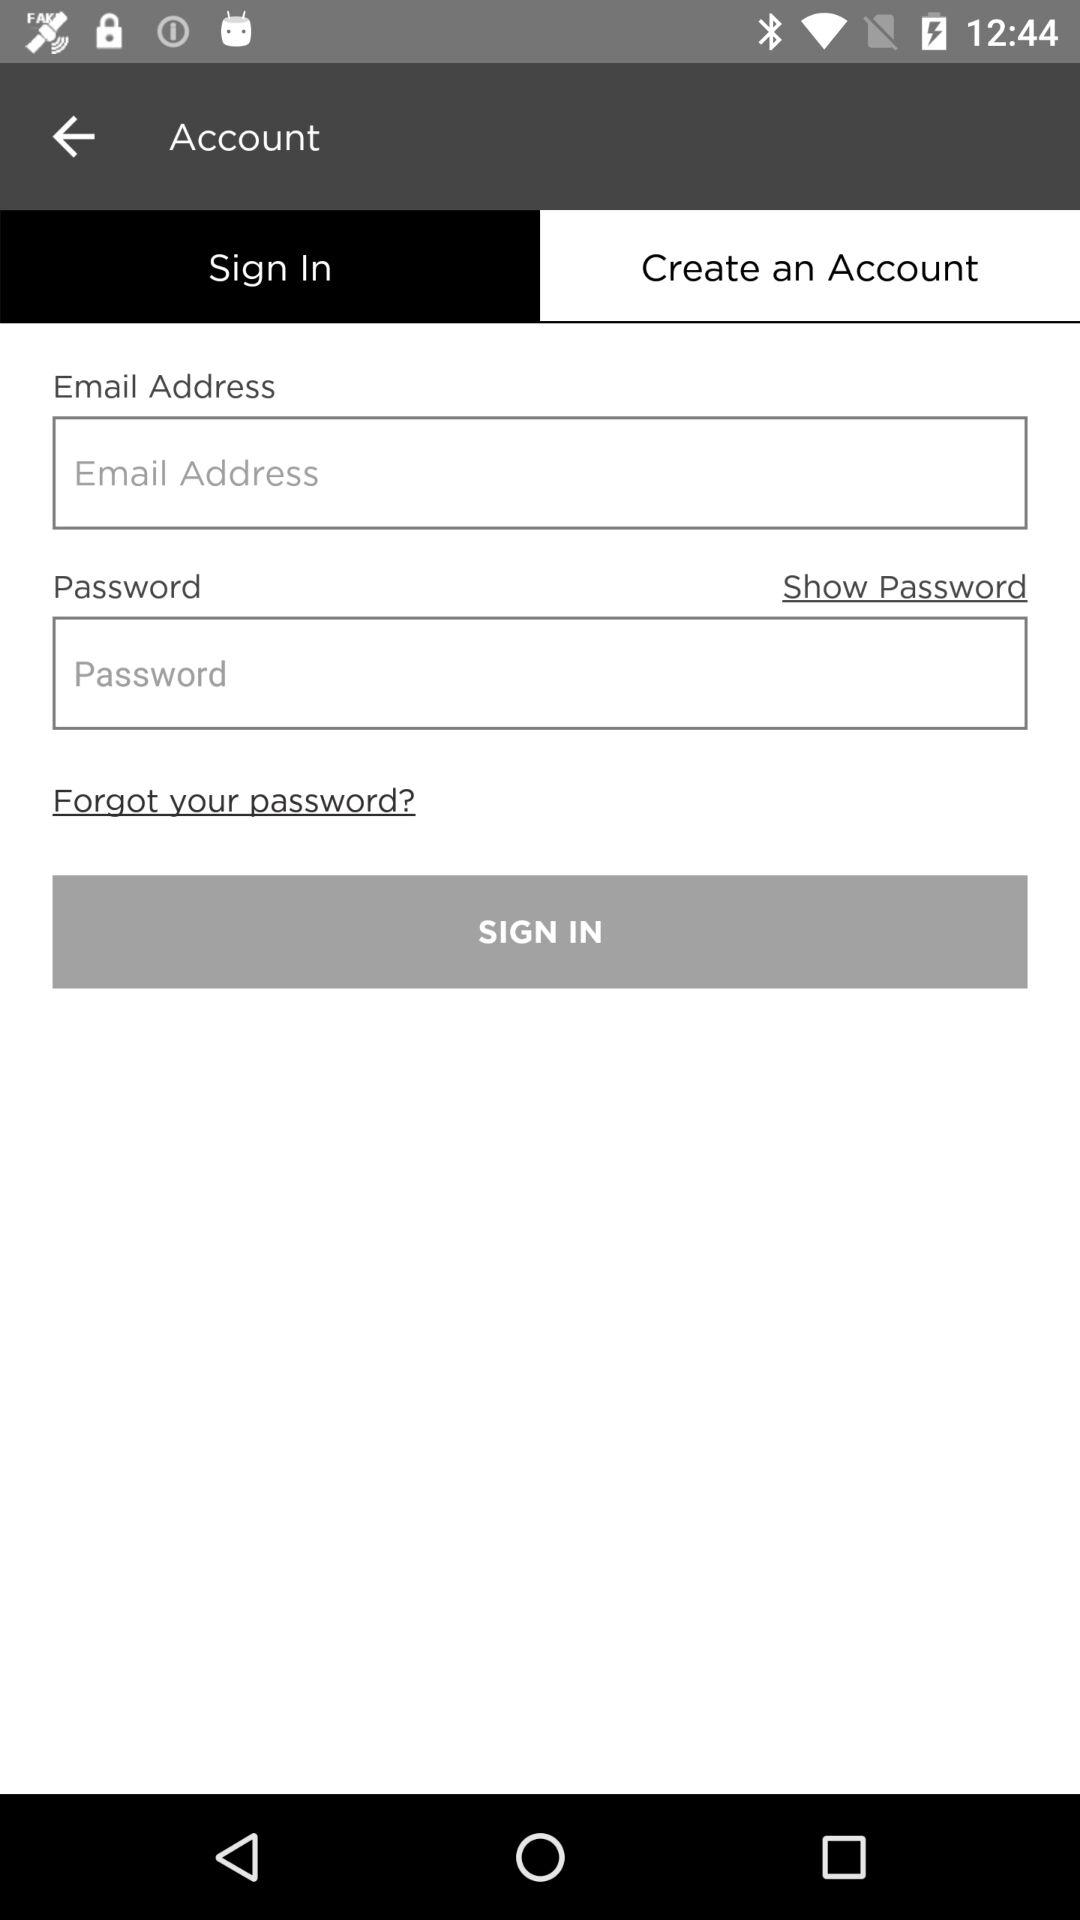Which pieces of personal information are required for creating an account?
When the provided information is insufficient, respond with <no answer>. <no answer> 